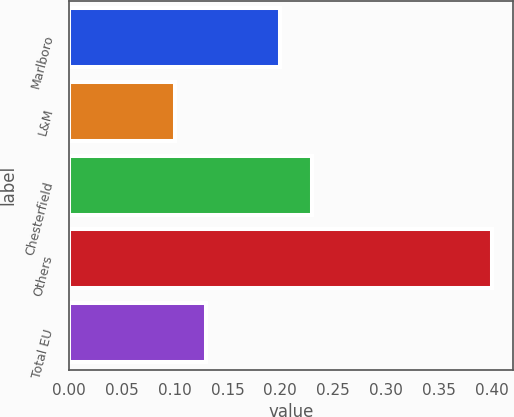Convert chart to OTSL. <chart><loc_0><loc_0><loc_500><loc_500><bar_chart><fcel>Marlboro<fcel>L&M<fcel>Chesterfield<fcel>Others<fcel>Total EU<nl><fcel>0.2<fcel>0.1<fcel>0.23<fcel>0.4<fcel>0.13<nl></chart> 